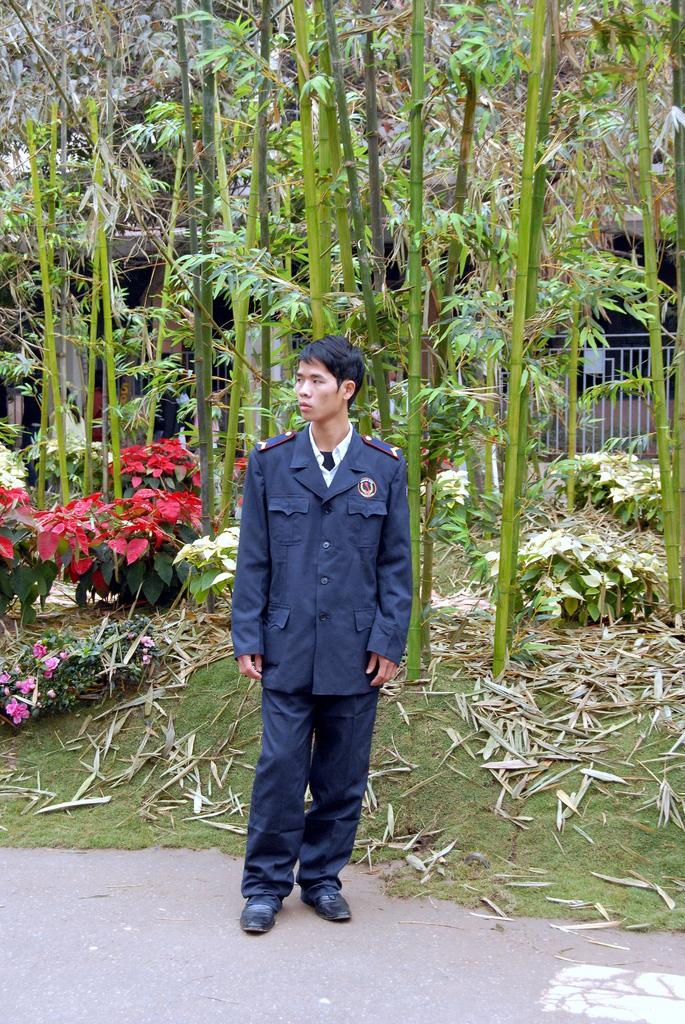What is present in the image? There is a person in the image. What can be seen in the background of the image? There are plants, grass, a grill, and trees in the background of the image. What type of prose is the person in the image reading? There is no indication in the image that the person is reading any prose. 